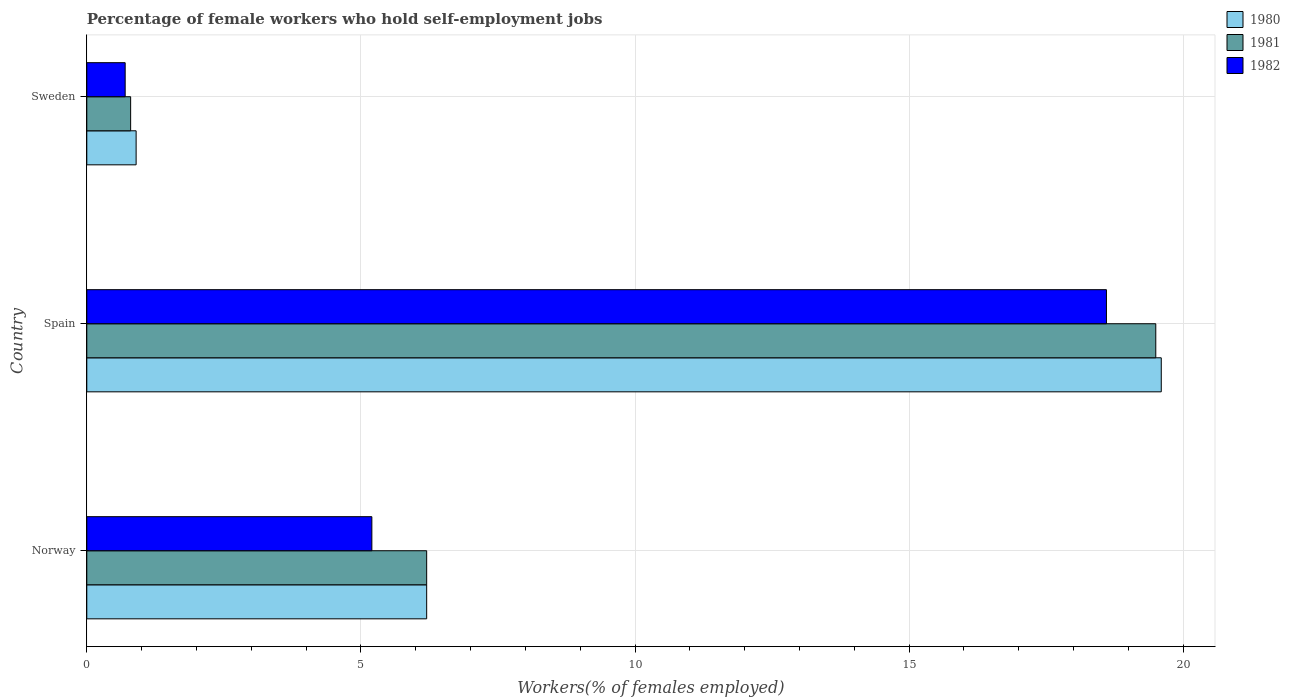Are the number of bars per tick equal to the number of legend labels?
Your response must be concise. Yes. Are the number of bars on each tick of the Y-axis equal?
Your response must be concise. Yes. How many bars are there on the 2nd tick from the top?
Give a very brief answer. 3. How many bars are there on the 1st tick from the bottom?
Provide a succinct answer. 3. What is the label of the 2nd group of bars from the top?
Provide a succinct answer. Spain. What is the percentage of self-employed female workers in 1980 in Sweden?
Offer a very short reply. 0.9. Across all countries, what is the maximum percentage of self-employed female workers in 1982?
Make the answer very short. 18.6. Across all countries, what is the minimum percentage of self-employed female workers in 1980?
Make the answer very short. 0.9. What is the total percentage of self-employed female workers in 1981 in the graph?
Your answer should be compact. 26.5. What is the difference between the percentage of self-employed female workers in 1980 in Norway and that in Sweden?
Ensure brevity in your answer.  5.3. What is the difference between the percentage of self-employed female workers in 1981 in Spain and the percentage of self-employed female workers in 1982 in Sweden?
Your response must be concise. 18.8. What is the average percentage of self-employed female workers in 1981 per country?
Ensure brevity in your answer.  8.83. What is the difference between the percentage of self-employed female workers in 1981 and percentage of self-employed female workers in 1982 in Sweden?
Provide a short and direct response. 0.1. In how many countries, is the percentage of self-employed female workers in 1981 greater than 18 %?
Ensure brevity in your answer.  1. What is the ratio of the percentage of self-employed female workers in 1982 in Spain to that in Sweden?
Ensure brevity in your answer.  26.57. What is the difference between the highest and the second highest percentage of self-employed female workers in 1980?
Provide a short and direct response. 13.4. What is the difference between the highest and the lowest percentage of self-employed female workers in 1982?
Provide a succinct answer. 17.9. In how many countries, is the percentage of self-employed female workers in 1981 greater than the average percentage of self-employed female workers in 1981 taken over all countries?
Offer a very short reply. 1. What is the difference between two consecutive major ticks on the X-axis?
Make the answer very short. 5. Does the graph contain any zero values?
Provide a short and direct response. No. Does the graph contain grids?
Your response must be concise. Yes. Where does the legend appear in the graph?
Your answer should be very brief. Top right. How many legend labels are there?
Offer a very short reply. 3. How are the legend labels stacked?
Offer a very short reply. Vertical. What is the title of the graph?
Ensure brevity in your answer.  Percentage of female workers who hold self-employment jobs. Does "1997" appear as one of the legend labels in the graph?
Keep it short and to the point. No. What is the label or title of the X-axis?
Your answer should be compact. Workers(% of females employed). What is the Workers(% of females employed) in 1980 in Norway?
Make the answer very short. 6.2. What is the Workers(% of females employed) of 1981 in Norway?
Make the answer very short. 6.2. What is the Workers(% of females employed) of 1982 in Norway?
Your answer should be very brief. 5.2. What is the Workers(% of females employed) of 1980 in Spain?
Ensure brevity in your answer.  19.6. What is the Workers(% of females employed) in 1982 in Spain?
Your answer should be compact. 18.6. What is the Workers(% of females employed) of 1980 in Sweden?
Make the answer very short. 0.9. What is the Workers(% of females employed) in 1981 in Sweden?
Your answer should be compact. 0.8. What is the Workers(% of females employed) in 1982 in Sweden?
Keep it short and to the point. 0.7. Across all countries, what is the maximum Workers(% of females employed) in 1980?
Offer a terse response. 19.6. Across all countries, what is the maximum Workers(% of females employed) of 1982?
Offer a very short reply. 18.6. Across all countries, what is the minimum Workers(% of females employed) of 1980?
Provide a succinct answer. 0.9. Across all countries, what is the minimum Workers(% of females employed) of 1981?
Your answer should be compact. 0.8. Across all countries, what is the minimum Workers(% of females employed) in 1982?
Keep it short and to the point. 0.7. What is the total Workers(% of females employed) of 1980 in the graph?
Your answer should be very brief. 26.7. What is the total Workers(% of females employed) in 1981 in the graph?
Your answer should be compact. 26.5. What is the total Workers(% of females employed) in 1982 in the graph?
Your response must be concise. 24.5. What is the difference between the Workers(% of females employed) of 1980 in Norway and that in Spain?
Provide a succinct answer. -13.4. What is the difference between the Workers(% of females employed) of 1980 in Norway and that in Sweden?
Your answer should be compact. 5.3. What is the difference between the Workers(% of females employed) in 1982 in Norway and that in Sweden?
Provide a succinct answer. 4.5. What is the difference between the Workers(% of females employed) of 1982 in Spain and that in Sweden?
Your response must be concise. 17.9. What is the difference between the Workers(% of females employed) of 1981 in Norway and the Workers(% of females employed) of 1982 in Spain?
Give a very brief answer. -12.4. What is the difference between the Workers(% of females employed) in 1980 in Spain and the Workers(% of females employed) in 1982 in Sweden?
Your answer should be very brief. 18.9. What is the average Workers(% of females employed) of 1981 per country?
Provide a succinct answer. 8.83. What is the average Workers(% of females employed) of 1982 per country?
Your response must be concise. 8.17. What is the difference between the Workers(% of females employed) of 1980 and Workers(% of females employed) of 1981 in Spain?
Offer a very short reply. 0.1. What is the difference between the Workers(% of females employed) of 1980 and Workers(% of females employed) of 1982 in Spain?
Ensure brevity in your answer.  1. What is the difference between the Workers(% of females employed) in 1980 and Workers(% of females employed) in 1981 in Sweden?
Offer a terse response. 0.1. What is the difference between the Workers(% of females employed) in 1981 and Workers(% of females employed) in 1982 in Sweden?
Your answer should be very brief. 0.1. What is the ratio of the Workers(% of females employed) of 1980 in Norway to that in Spain?
Ensure brevity in your answer.  0.32. What is the ratio of the Workers(% of females employed) of 1981 in Norway to that in Spain?
Keep it short and to the point. 0.32. What is the ratio of the Workers(% of females employed) in 1982 in Norway to that in Spain?
Keep it short and to the point. 0.28. What is the ratio of the Workers(% of females employed) of 1980 in Norway to that in Sweden?
Make the answer very short. 6.89. What is the ratio of the Workers(% of females employed) in 1981 in Norway to that in Sweden?
Your response must be concise. 7.75. What is the ratio of the Workers(% of females employed) in 1982 in Norway to that in Sweden?
Offer a terse response. 7.43. What is the ratio of the Workers(% of females employed) of 1980 in Spain to that in Sweden?
Your answer should be very brief. 21.78. What is the ratio of the Workers(% of females employed) in 1981 in Spain to that in Sweden?
Make the answer very short. 24.38. What is the ratio of the Workers(% of females employed) in 1982 in Spain to that in Sweden?
Give a very brief answer. 26.57. 